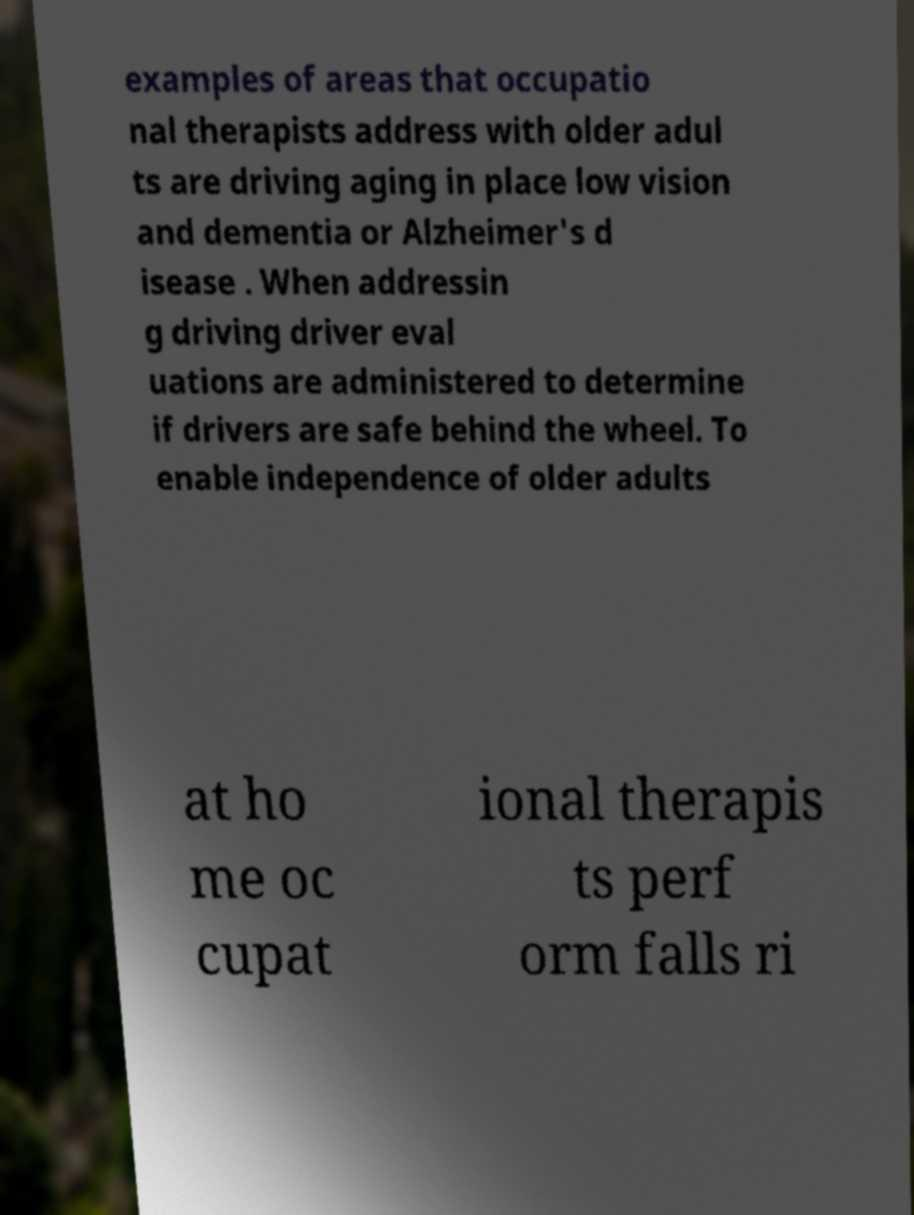I need the written content from this picture converted into text. Can you do that? examples of areas that occupatio nal therapists address with older adul ts are driving aging in place low vision and dementia or Alzheimer's d isease . When addressin g driving driver eval uations are administered to determine if drivers are safe behind the wheel. To enable independence of older adults at ho me oc cupat ional therapis ts perf orm falls ri 